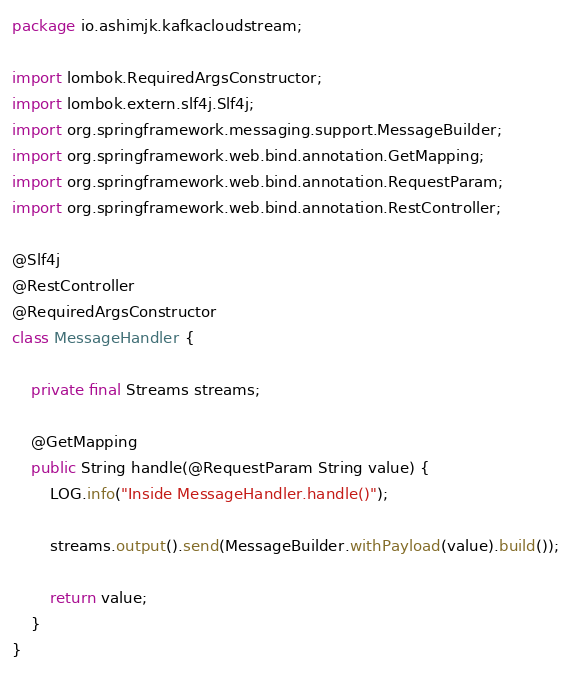Convert code to text. <code><loc_0><loc_0><loc_500><loc_500><_Java_>package io.ashimjk.kafkacloudstream;

import lombok.RequiredArgsConstructor;
import lombok.extern.slf4j.Slf4j;
import org.springframework.messaging.support.MessageBuilder;
import org.springframework.web.bind.annotation.GetMapping;
import org.springframework.web.bind.annotation.RequestParam;
import org.springframework.web.bind.annotation.RestController;

@Slf4j
@RestController
@RequiredArgsConstructor
class MessageHandler {

    private final Streams streams;

    @GetMapping
    public String handle(@RequestParam String value) {
        LOG.info("Inside MessageHandler.handle()");

        streams.output().send(MessageBuilder.withPayload(value).build());

        return value;
    }
}
</code> 